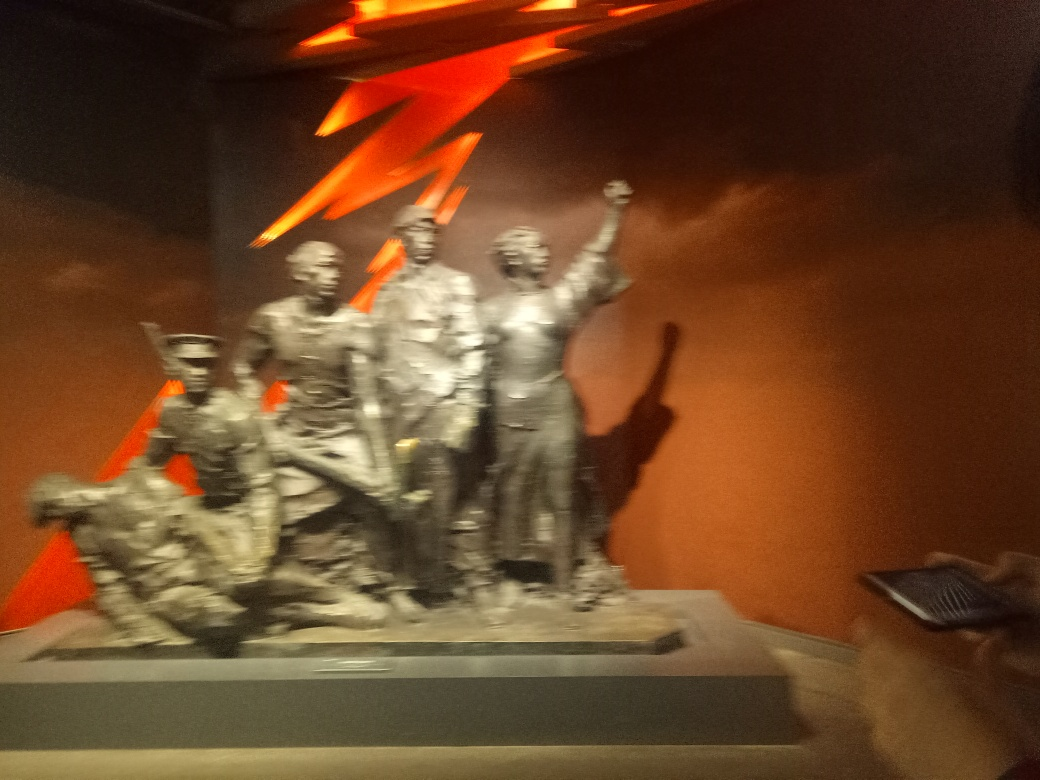How many figures can you identify in the sculpture? The image is a bit too blurry to count with precision, but it appears to contain at least five figures. They are positioned in a way that suggests a cohesive group, united by a common cause or event. 